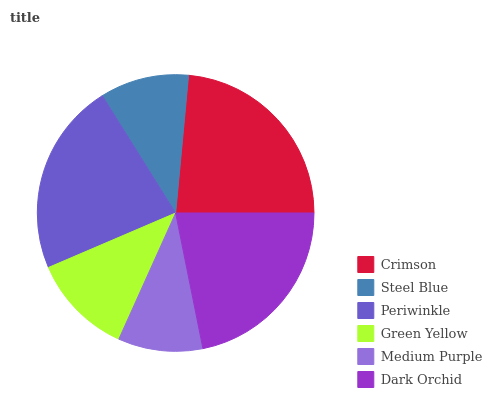Is Medium Purple the minimum?
Answer yes or no. Yes. Is Crimson the maximum?
Answer yes or no. Yes. Is Steel Blue the minimum?
Answer yes or no. No. Is Steel Blue the maximum?
Answer yes or no. No. Is Crimson greater than Steel Blue?
Answer yes or no. Yes. Is Steel Blue less than Crimson?
Answer yes or no. Yes. Is Steel Blue greater than Crimson?
Answer yes or no. No. Is Crimson less than Steel Blue?
Answer yes or no. No. Is Dark Orchid the high median?
Answer yes or no. Yes. Is Green Yellow the low median?
Answer yes or no. Yes. Is Green Yellow the high median?
Answer yes or no. No. Is Crimson the low median?
Answer yes or no. No. 